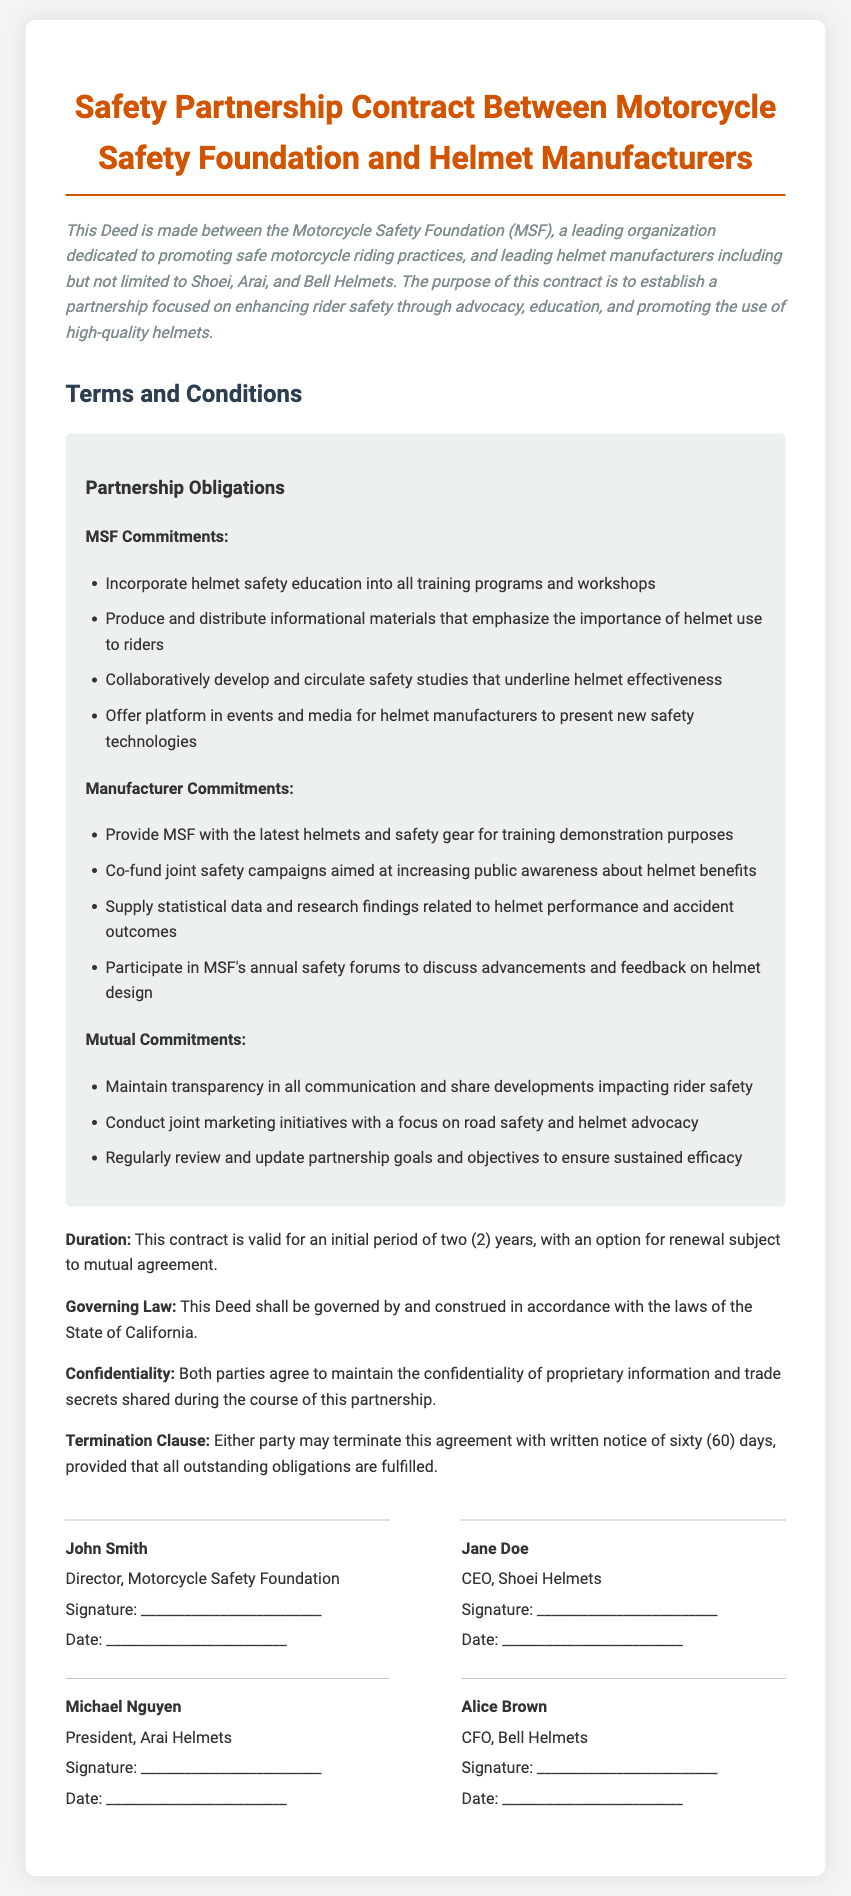What is the primary purpose of this contract? The primary purpose of this contract is to establish a partnership focused on enhancing rider safety through advocacy, education, and promoting the use of high-quality helmets.
Answer: enhancing rider safety Who is the Director of the Motorcycle Safety Foundation? This information can be found in the signatures section of the document, where the Director is listed.
Answer: John Smith How long is the initial validity period of the contract? The document specifies this validity period as part of the contract terms.
Answer: two (2) years Which companies are mentioned as helmet manufacturers? The document lists the helmet manufacturers involved in the contract.
Answer: Shoei, Arai, Bell Helmets What must be done for either party to terminate the agreement? The termination clause outlines the requirement for termination.
Answer: Written notice of sixty (60) days What commitment involves the distribution of informational materials? This commitment is part of the MSF obligations mentioned in the terms and conditions.
Answer: Produce and distribute informational materials What is required during joint marketing initiatives? The mutual commitments section specifies the focus for these initiatives.
Answer: road safety and helmet advocacy Which law governs this contract? The governing law section states the legal jurisdiction for the contract.
Answer: State of California What type of information must both parties maintain confidentiality about? The confidentiality clause outlines the types of information that are to remain private.
Answer: proprietary information and trade secrets 